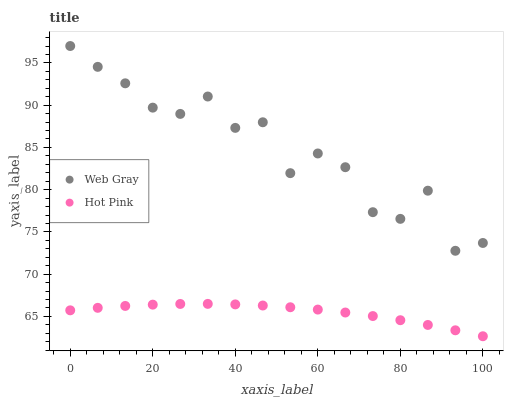Does Hot Pink have the minimum area under the curve?
Answer yes or no. Yes. Does Web Gray have the maximum area under the curve?
Answer yes or no. Yes. Does Hot Pink have the maximum area under the curve?
Answer yes or no. No. Is Hot Pink the smoothest?
Answer yes or no. Yes. Is Web Gray the roughest?
Answer yes or no. Yes. Is Hot Pink the roughest?
Answer yes or no. No. Does Hot Pink have the lowest value?
Answer yes or no. Yes. Does Web Gray have the highest value?
Answer yes or no. Yes. Does Hot Pink have the highest value?
Answer yes or no. No. Is Hot Pink less than Web Gray?
Answer yes or no. Yes. Is Web Gray greater than Hot Pink?
Answer yes or no. Yes. Does Hot Pink intersect Web Gray?
Answer yes or no. No. 